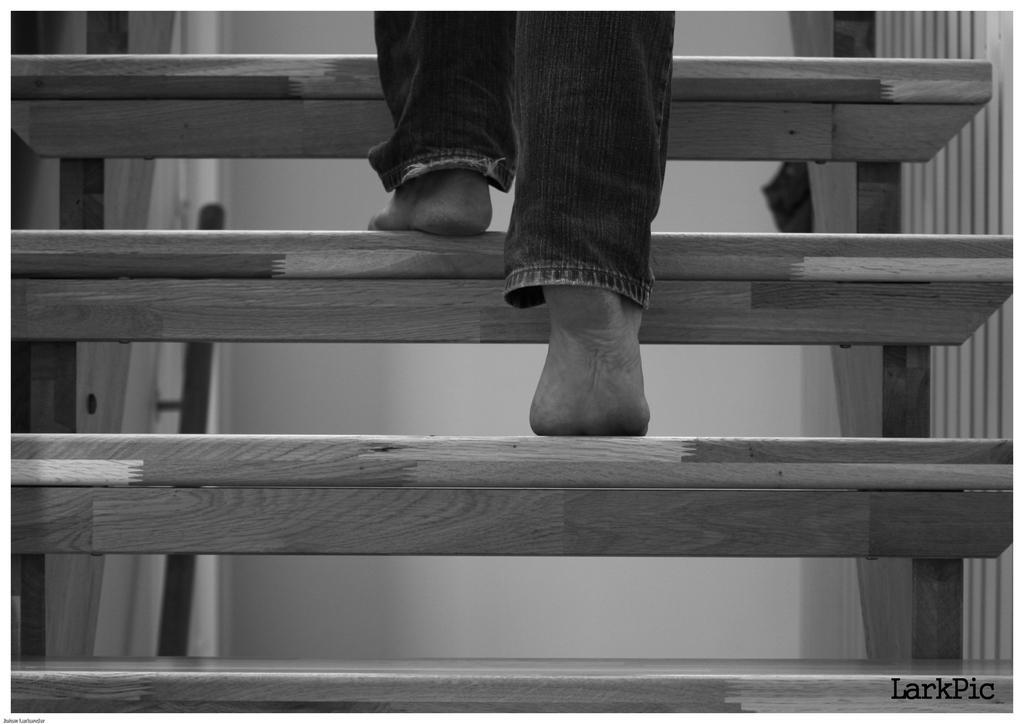Please provide a concise description of this image. In this image I can see the stairs and I can see the person legs on the stairs. In the back there's a wall. And this a black and white image. 